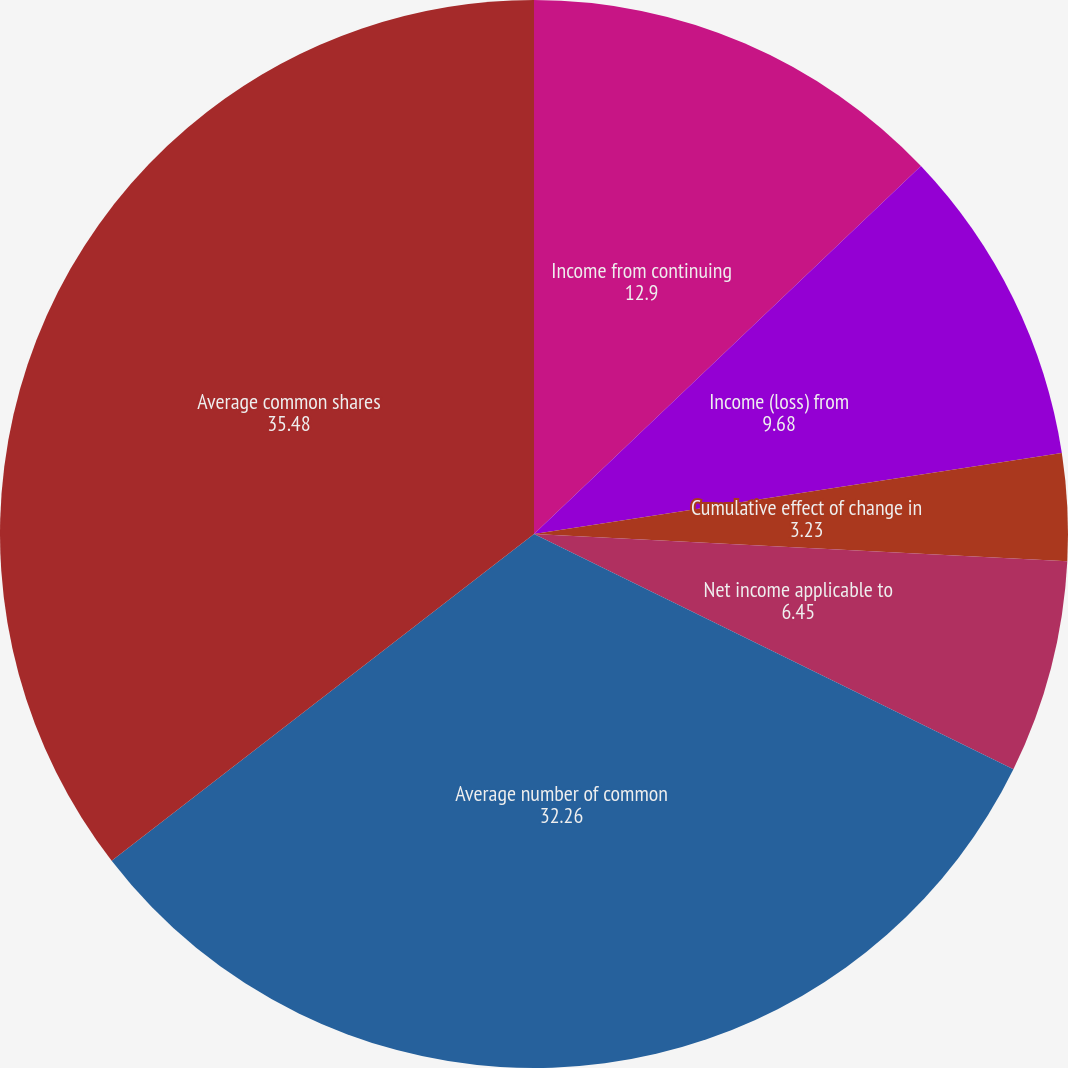<chart> <loc_0><loc_0><loc_500><loc_500><pie_chart><fcel>Income from continuing<fcel>Income (loss) from<fcel>Cumulative effect of change in<fcel>Net income applicable to<fcel>Average number of common<fcel>Average common shares<fcel>Net income<nl><fcel>12.9%<fcel>9.68%<fcel>3.23%<fcel>6.45%<fcel>32.26%<fcel>35.48%<fcel>0.0%<nl></chart> 